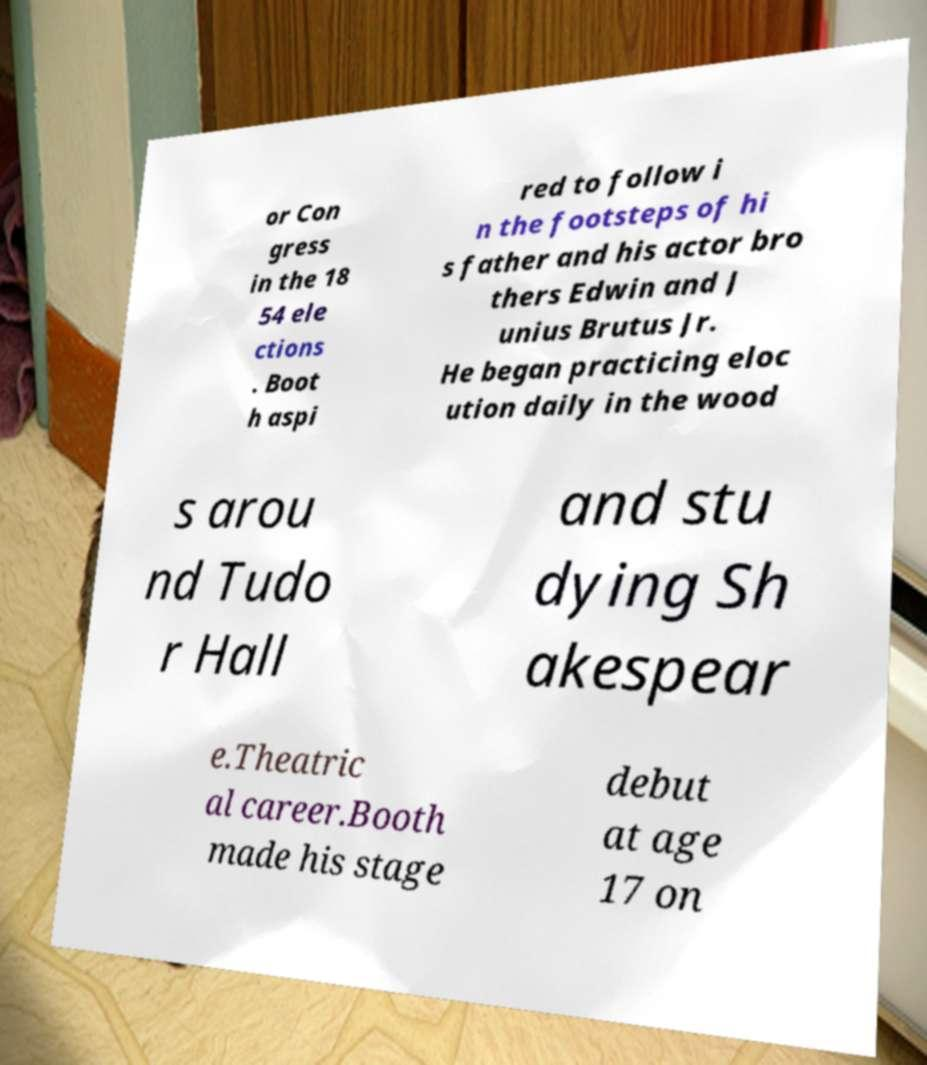For documentation purposes, I need the text within this image transcribed. Could you provide that? or Con gress in the 18 54 ele ctions . Boot h aspi red to follow i n the footsteps of hi s father and his actor bro thers Edwin and J unius Brutus Jr. He began practicing eloc ution daily in the wood s arou nd Tudo r Hall and stu dying Sh akespear e.Theatric al career.Booth made his stage debut at age 17 on 